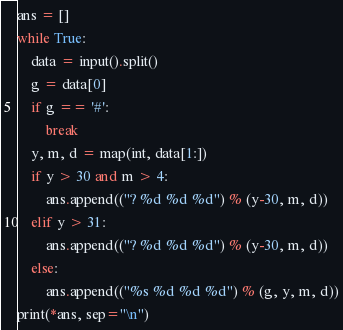<code> <loc_0><loc_0><loc_500><loc_500><_Python_>ans = []
while True:
    data = input().split()
    g = data[0]
    if g == '#':
        break
    y, m, d = map(int, data[1:])
    if y > 30 and m > 4:
        ans.append(("? %d %d %d") % (y-30, m, d))
    elif y > 31:
        ans.append(("? %d %d %d") % (y-30, m, d))
    else:
        ans.append(("%s %d %d %d") % (g, y, m, d))
print(*ans, sep="\n")

</code> 